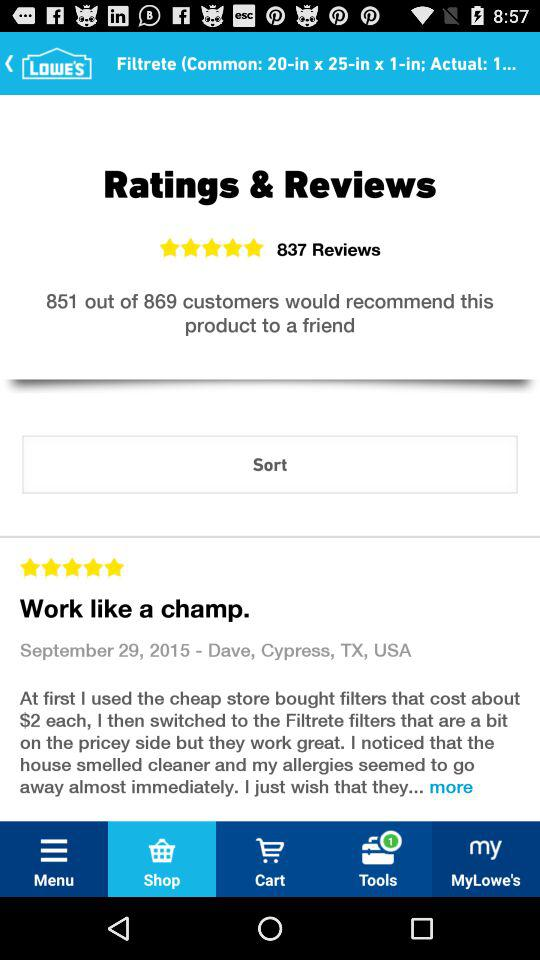What is the name of the application? The name of the application is "Lowe's". 